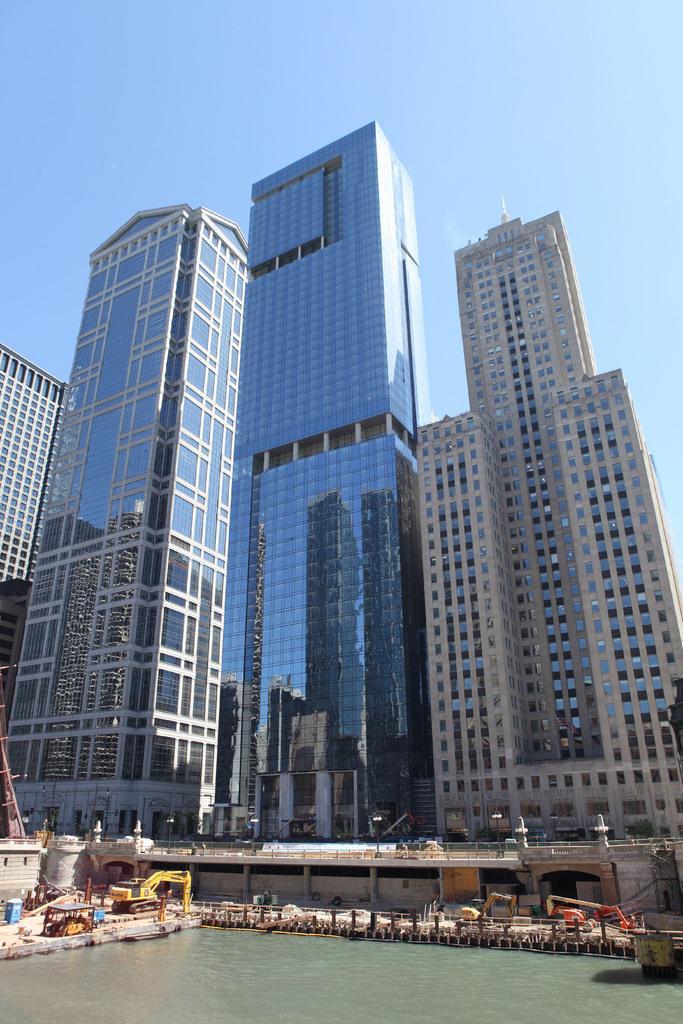Could you give a brief overview of what you see in this image? In this image there are buildings, in front of the buildings there is water. 